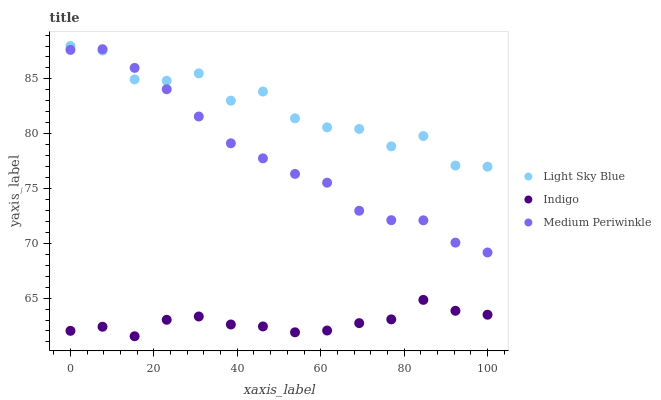Does Indigo have the minimum area under the curve?
Answer yes or no. Yes. Does Light Sky Blue have the maximum area under the curve?
Answer yes or no. Yes. Does Light Sky Blue have the minimum area under the curve?
Answer yes or no. No. Does Indigo have the maximum area under the curve?
Answer yes or no. No. Is Medium Periwinkle the smoothest?
Answer yes or no. Yes. Is Light Sky Blue the roughest?
Answer yes or no. Yes. Is Indigo the smoothest?
Answer yes or no. No. Is Indigo the roughest?
Answer yes or no. No. Does Indigo have the lowest value?
Answer yes or no. Yes. Does Light Sky Blue have the lowest value?
Answer yes or no. No. Does Light Sky Blue have the highest value?
Answer yes or no. Yes. Does Indigo have the highest value?
Answer yes or no. No. Is Indigo less than Medium Periwinkle?
Answer yes or no. Yes. Is Medium Periwinkle greater than Indigo?
Answer yes or no. Yes. Does Medium Periwinkle intersect Light Sky Blue?
Answer yes or no. Yes. Is Medium Periwinkle less than Light Sky Blue?
Answer yes or no. No. Is Medium Periwinkle greater than Light Sky Blue?
Answer yes or no. No. Does Indigo intersect Medium Periwinkle?
Answer yes or no. No. 